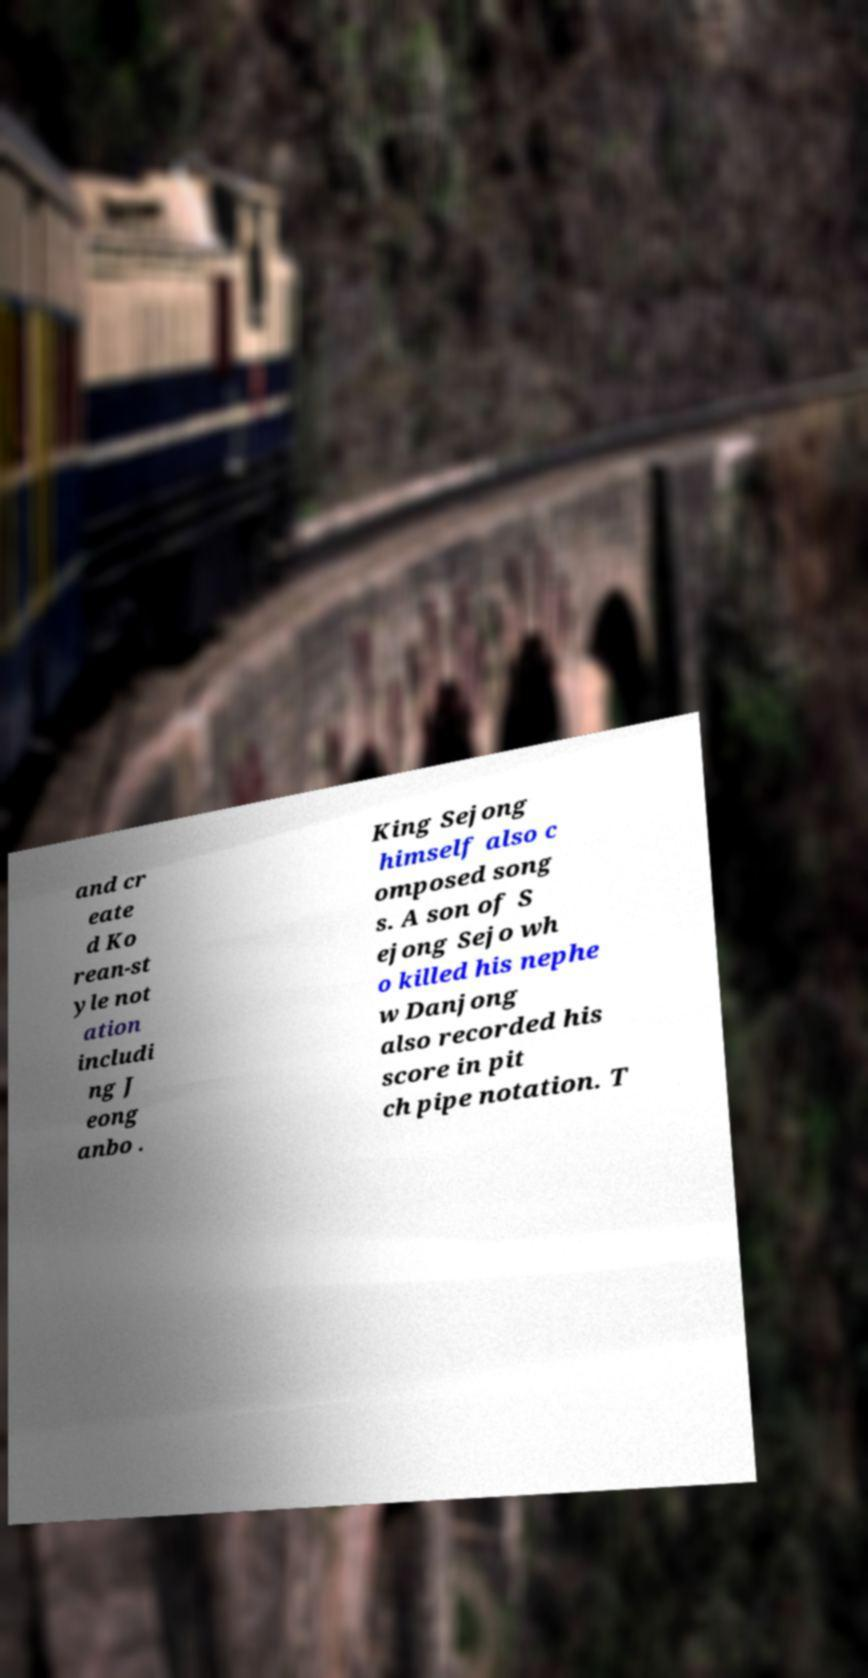For documentation purposes, I need the text within this image transcribed. Could you provide that? and cr eate d Ko rean-st yle not ation includi ng J eong anbo . King Sejong himself also c omposed song s. A son of S ejong Sejo wh o killed his nephe w Danjong also recorded his score in pit ch pipe notation. T 